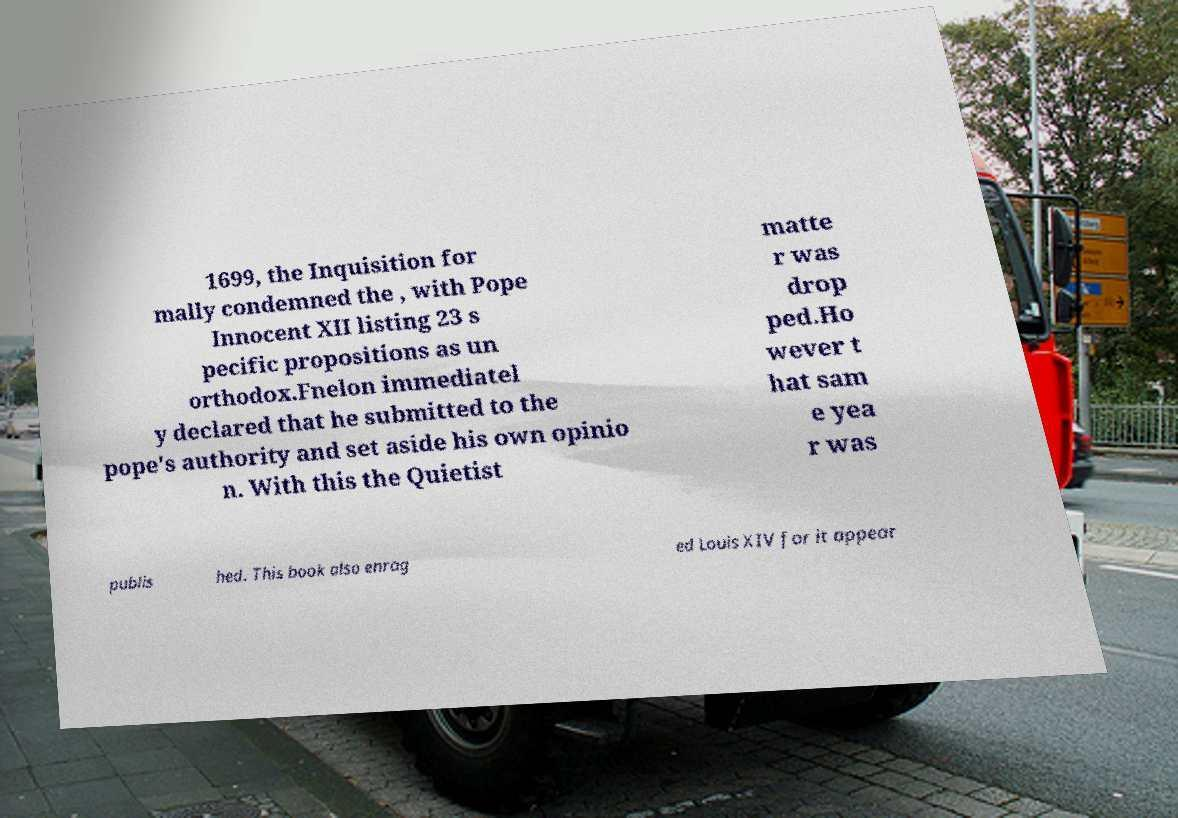Can you read and provide the text displayed in the image?This photo seems to have some interesting text. Can you extract and type it out for me? 1699, the Inquisition for mally condemned the , with Pope Innocent XII listing 23 s pecific propositions as un orthodox.Fnelon immediatel y declared that he submitted to the pope's authority and set aside his own opinio n. With this the Quietist matte r was drop ped.Ho wever t hat sam e yea r was publis hed. This book also enrag ed Louis XIV for it appear 